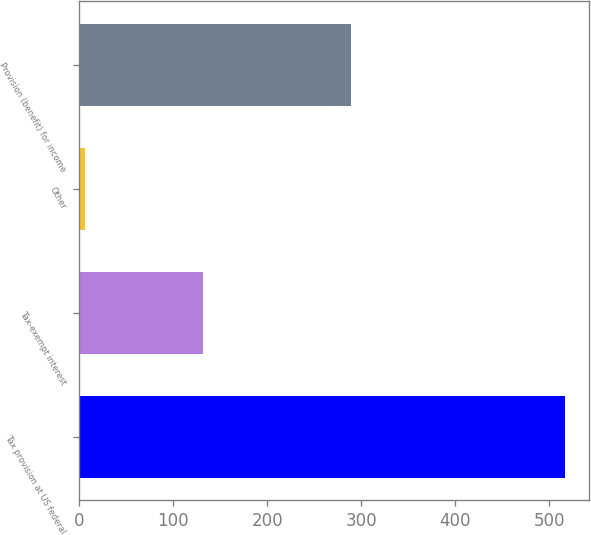Convert chart. <chart><loc_0><loc_0><loc_500><loc_500><bar_chart><fcel>Tax provision at US federal<fcel>Tax-exempt interest<fcel>Other<fcel>Provision (benefit) for income<nl><fcel>517<fcel>132<fcel>6<fcel>289<nl></chart> 